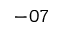Convert formula to latex. <formula><loc_0><loc_0><loc_500><loc_500>- 0 7</formula> 